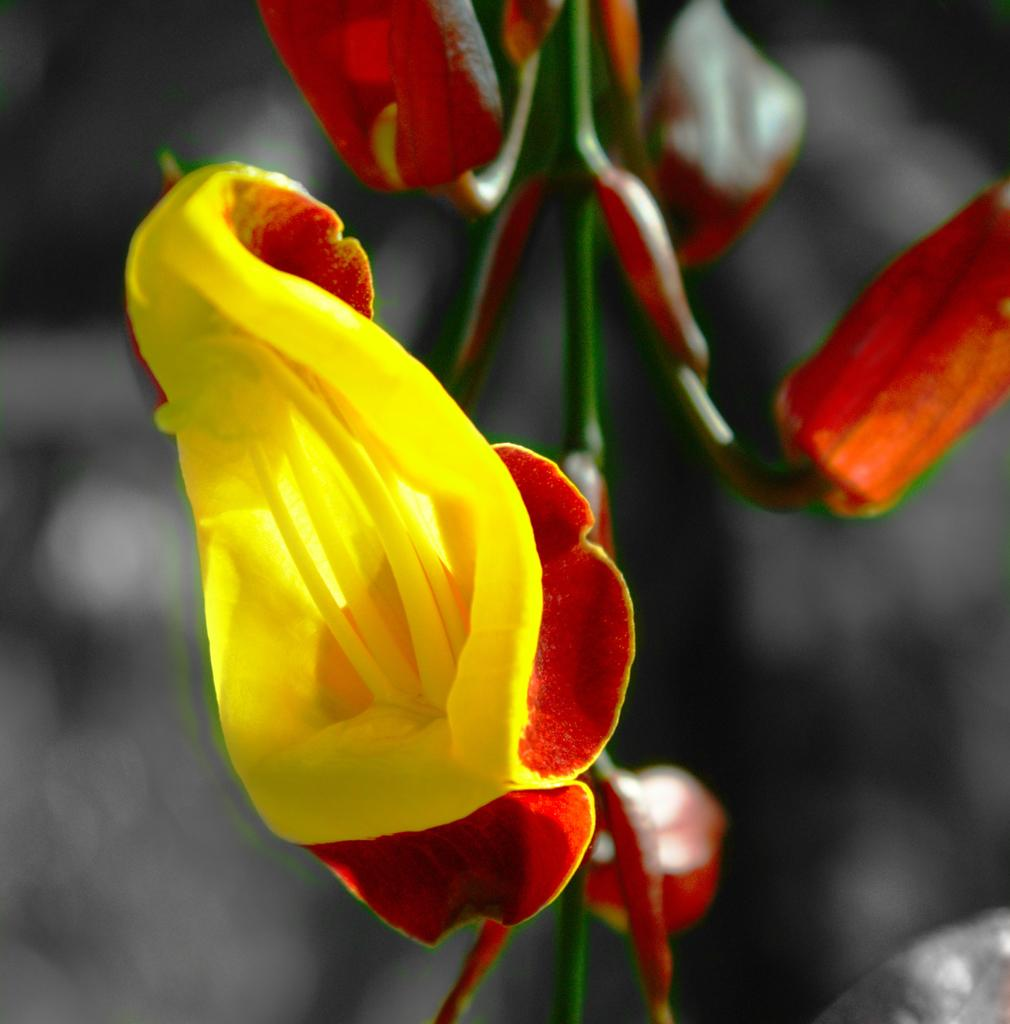What is the main subject of the image? There is a flower in the image. Are there any other parts of the flower visible in the image? Yes, there are buds in the image. Can you describe the background of the image? The background of the image is blurred. Where can the ducks be found in the image? There are no ducks present in the image. What type of market is depicted in the image? There is no market present in the image; it features a flower with buds and a blurred background. 